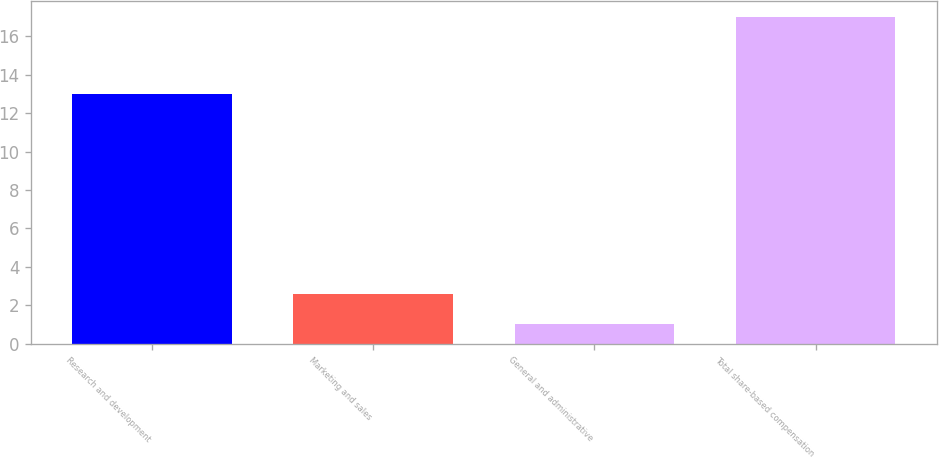Convert chart. <chart><loc_0><loc_0><loc_500><loc_500><bar_chart><fcel>Research and development<fcel>Marketing and sales<fcel>General and administrative<fcel>Total share-based compensation<nl><fcel>13<fcel>2.6<fcel>1<fcel>17<nl></chart> 